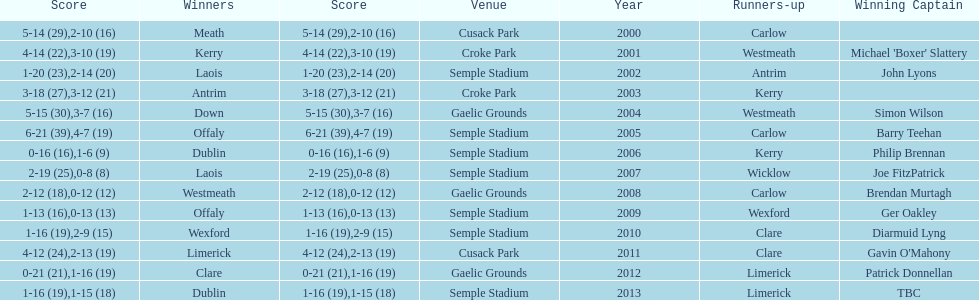Which team was the first to win with a team captain? Kerry. 